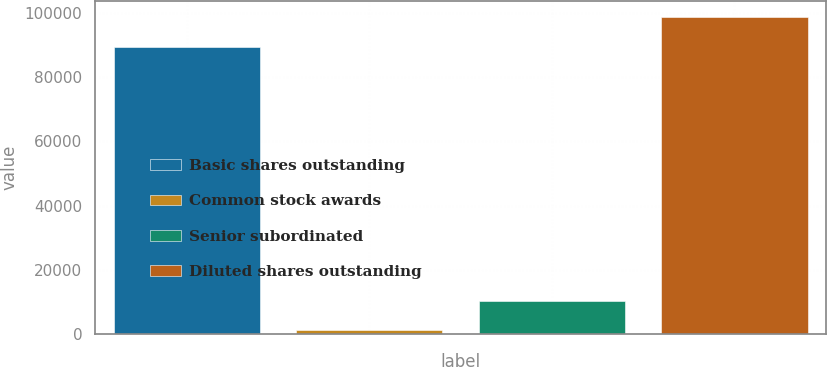Convert chart to OTSL. <chart><loc_0><loc_0><loc_500><loc_500><bar_chart><fcel>Basic shares outstanding<fcel>Common stock awards<fcel>Senior subordinated<fcel>Diluted shares outstanding<nl><fcel>89468<fcel>1155<fcel>10409.4<fcel>98722.4<nl></chart> 